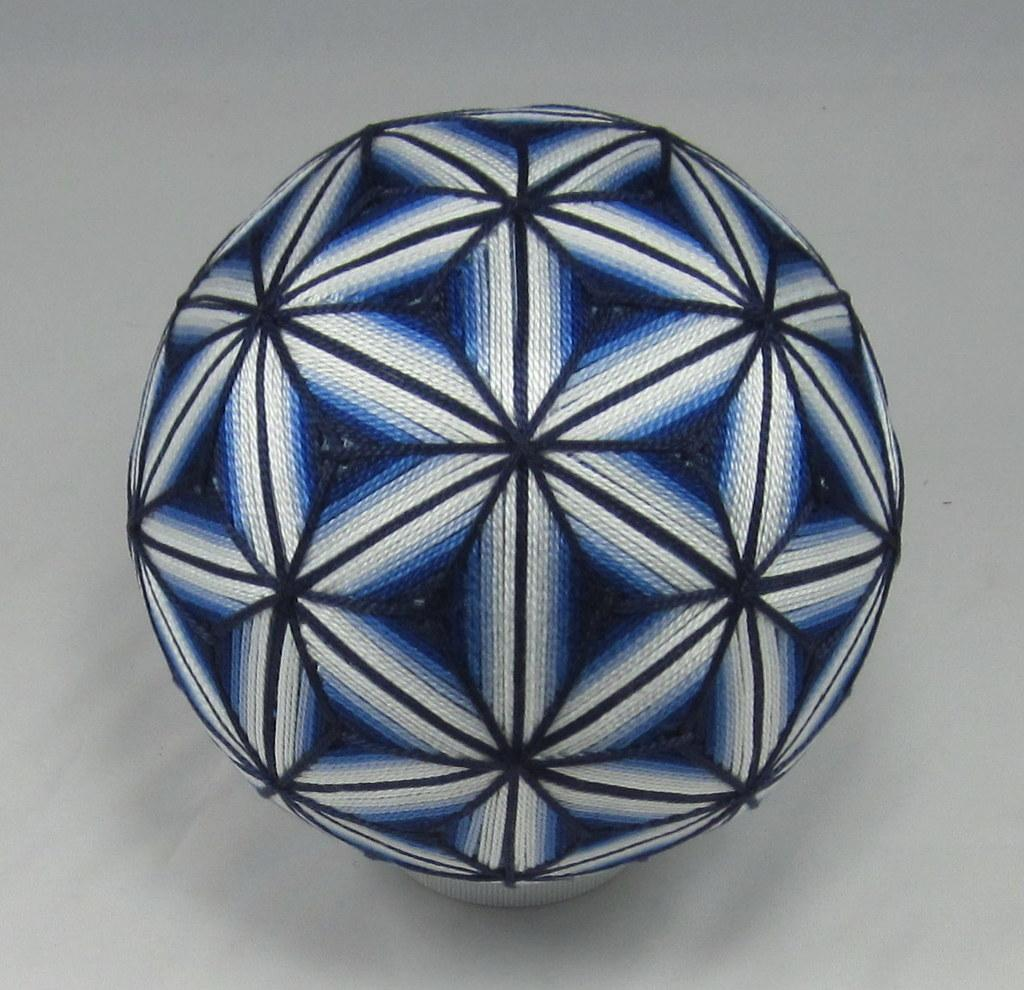What is the main object in the picture? There is a ball in the picture. Can you describe the colors of the ball? The ball has white and dark blue colors. What is the color of the background in the image? The background of the image is white. What type of club is visible in the image? There is no club present in the image; it features a ball with white and dark blue colors against a white background. How does the stomach of the ball feel in the image? The image does not depict a ball with a stomach, nor does it provide any information about the ball's feelings. 